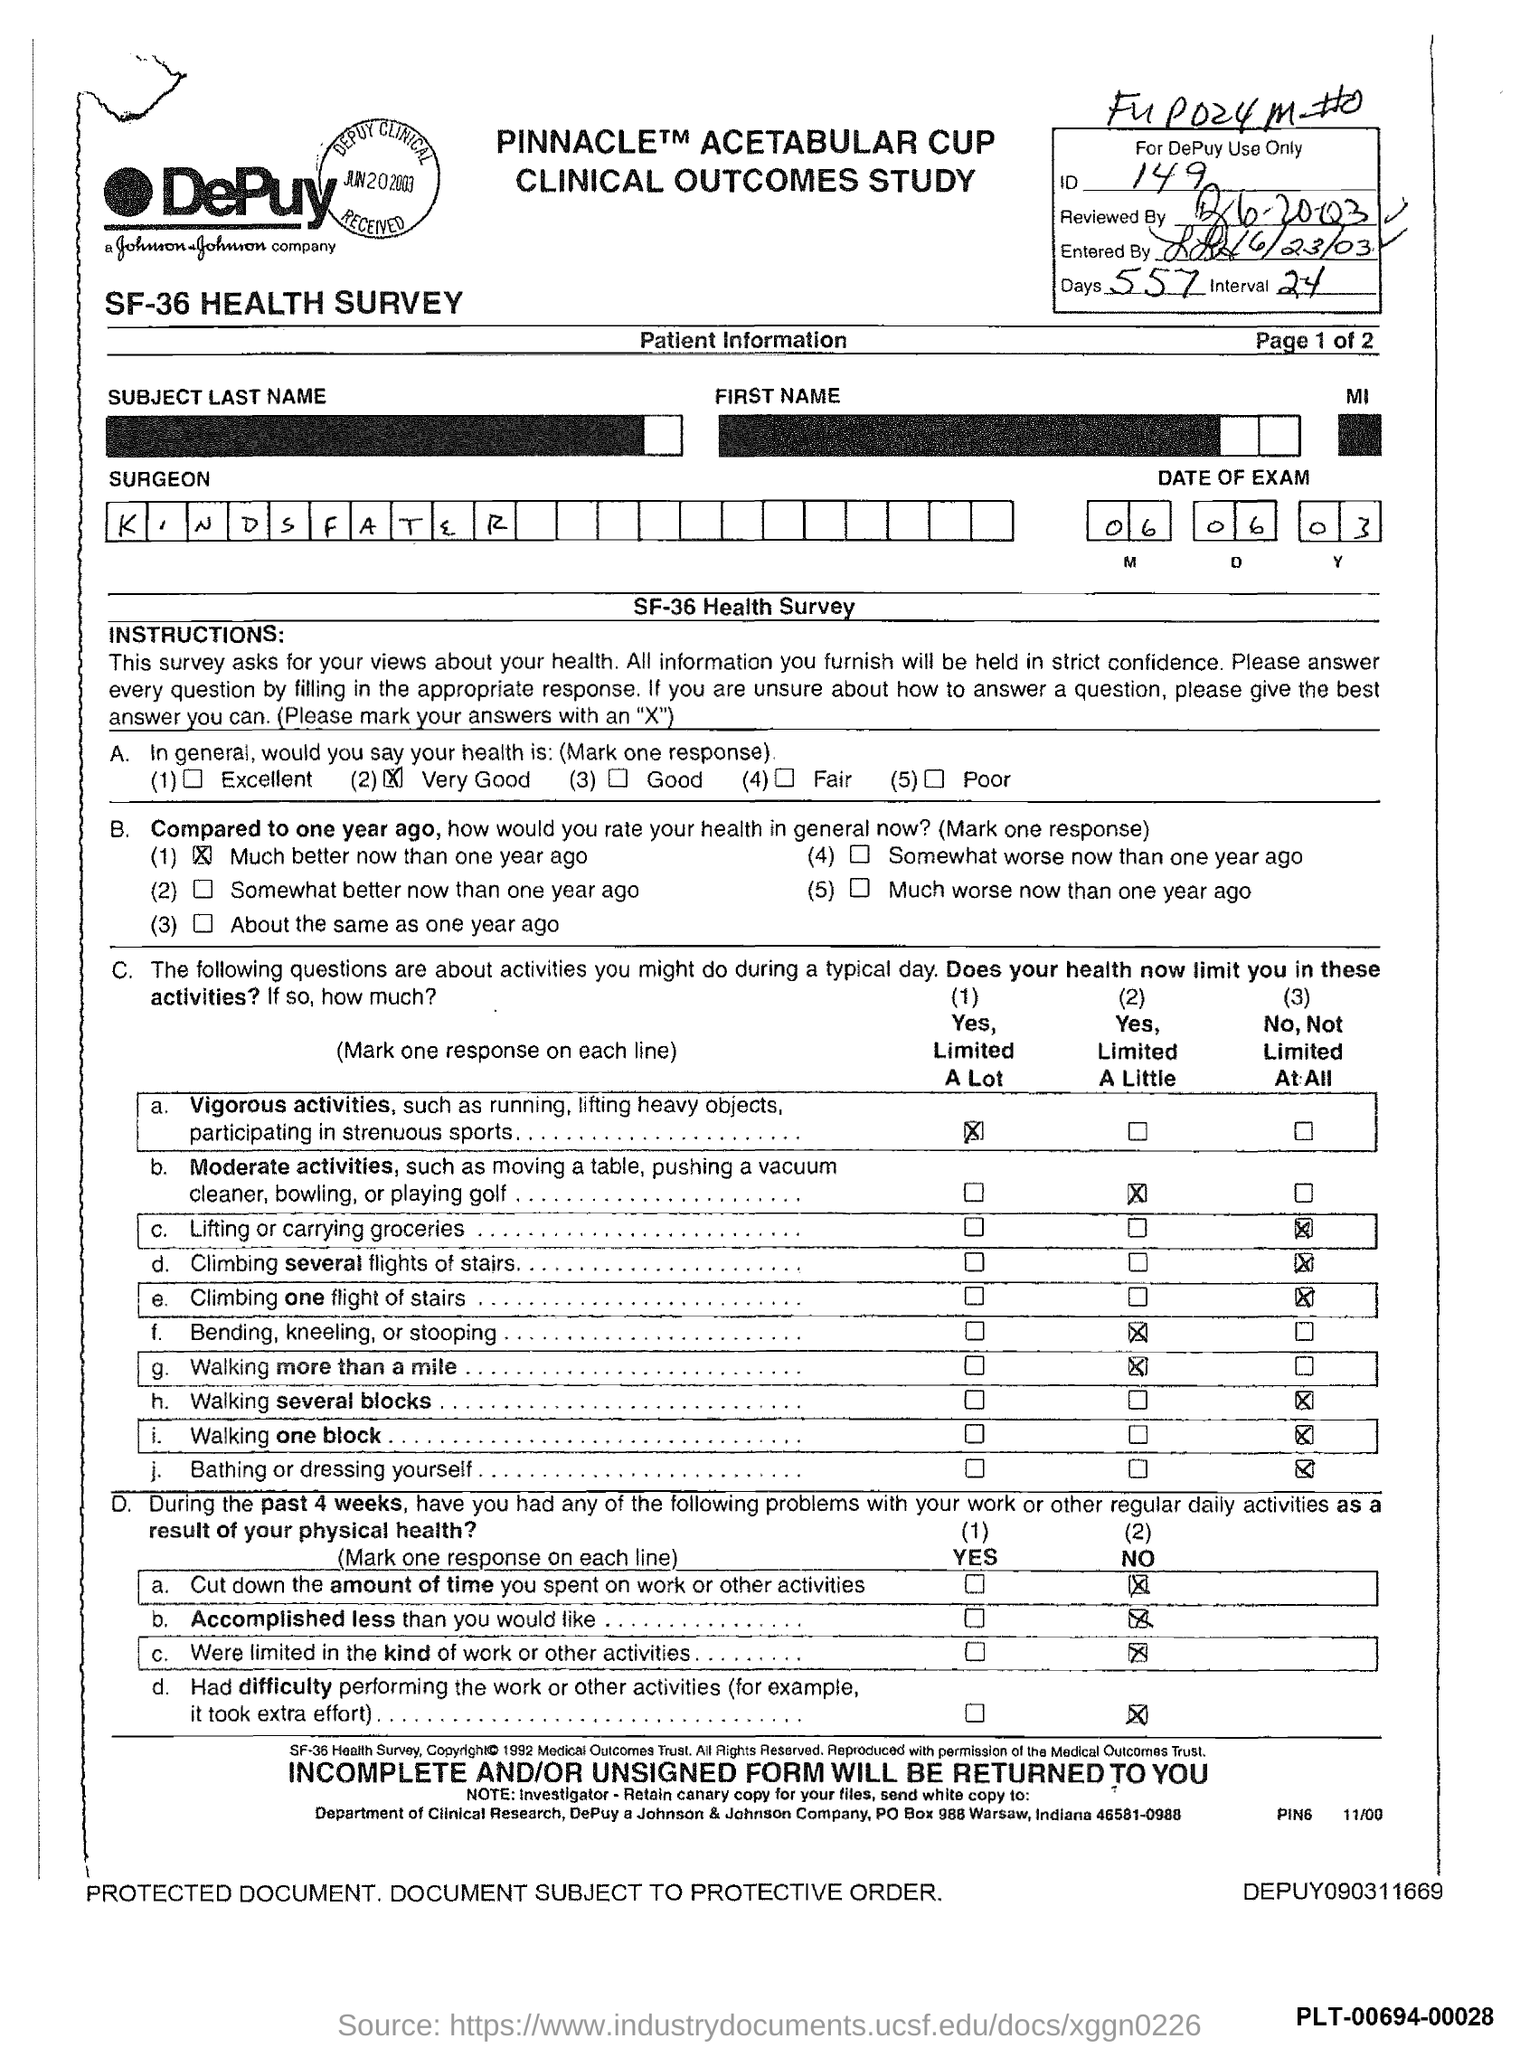Mention a couple of crucial points in this snapshot. The name of the surgeon is Kindsfater. What is the ID Number? It is 149... 